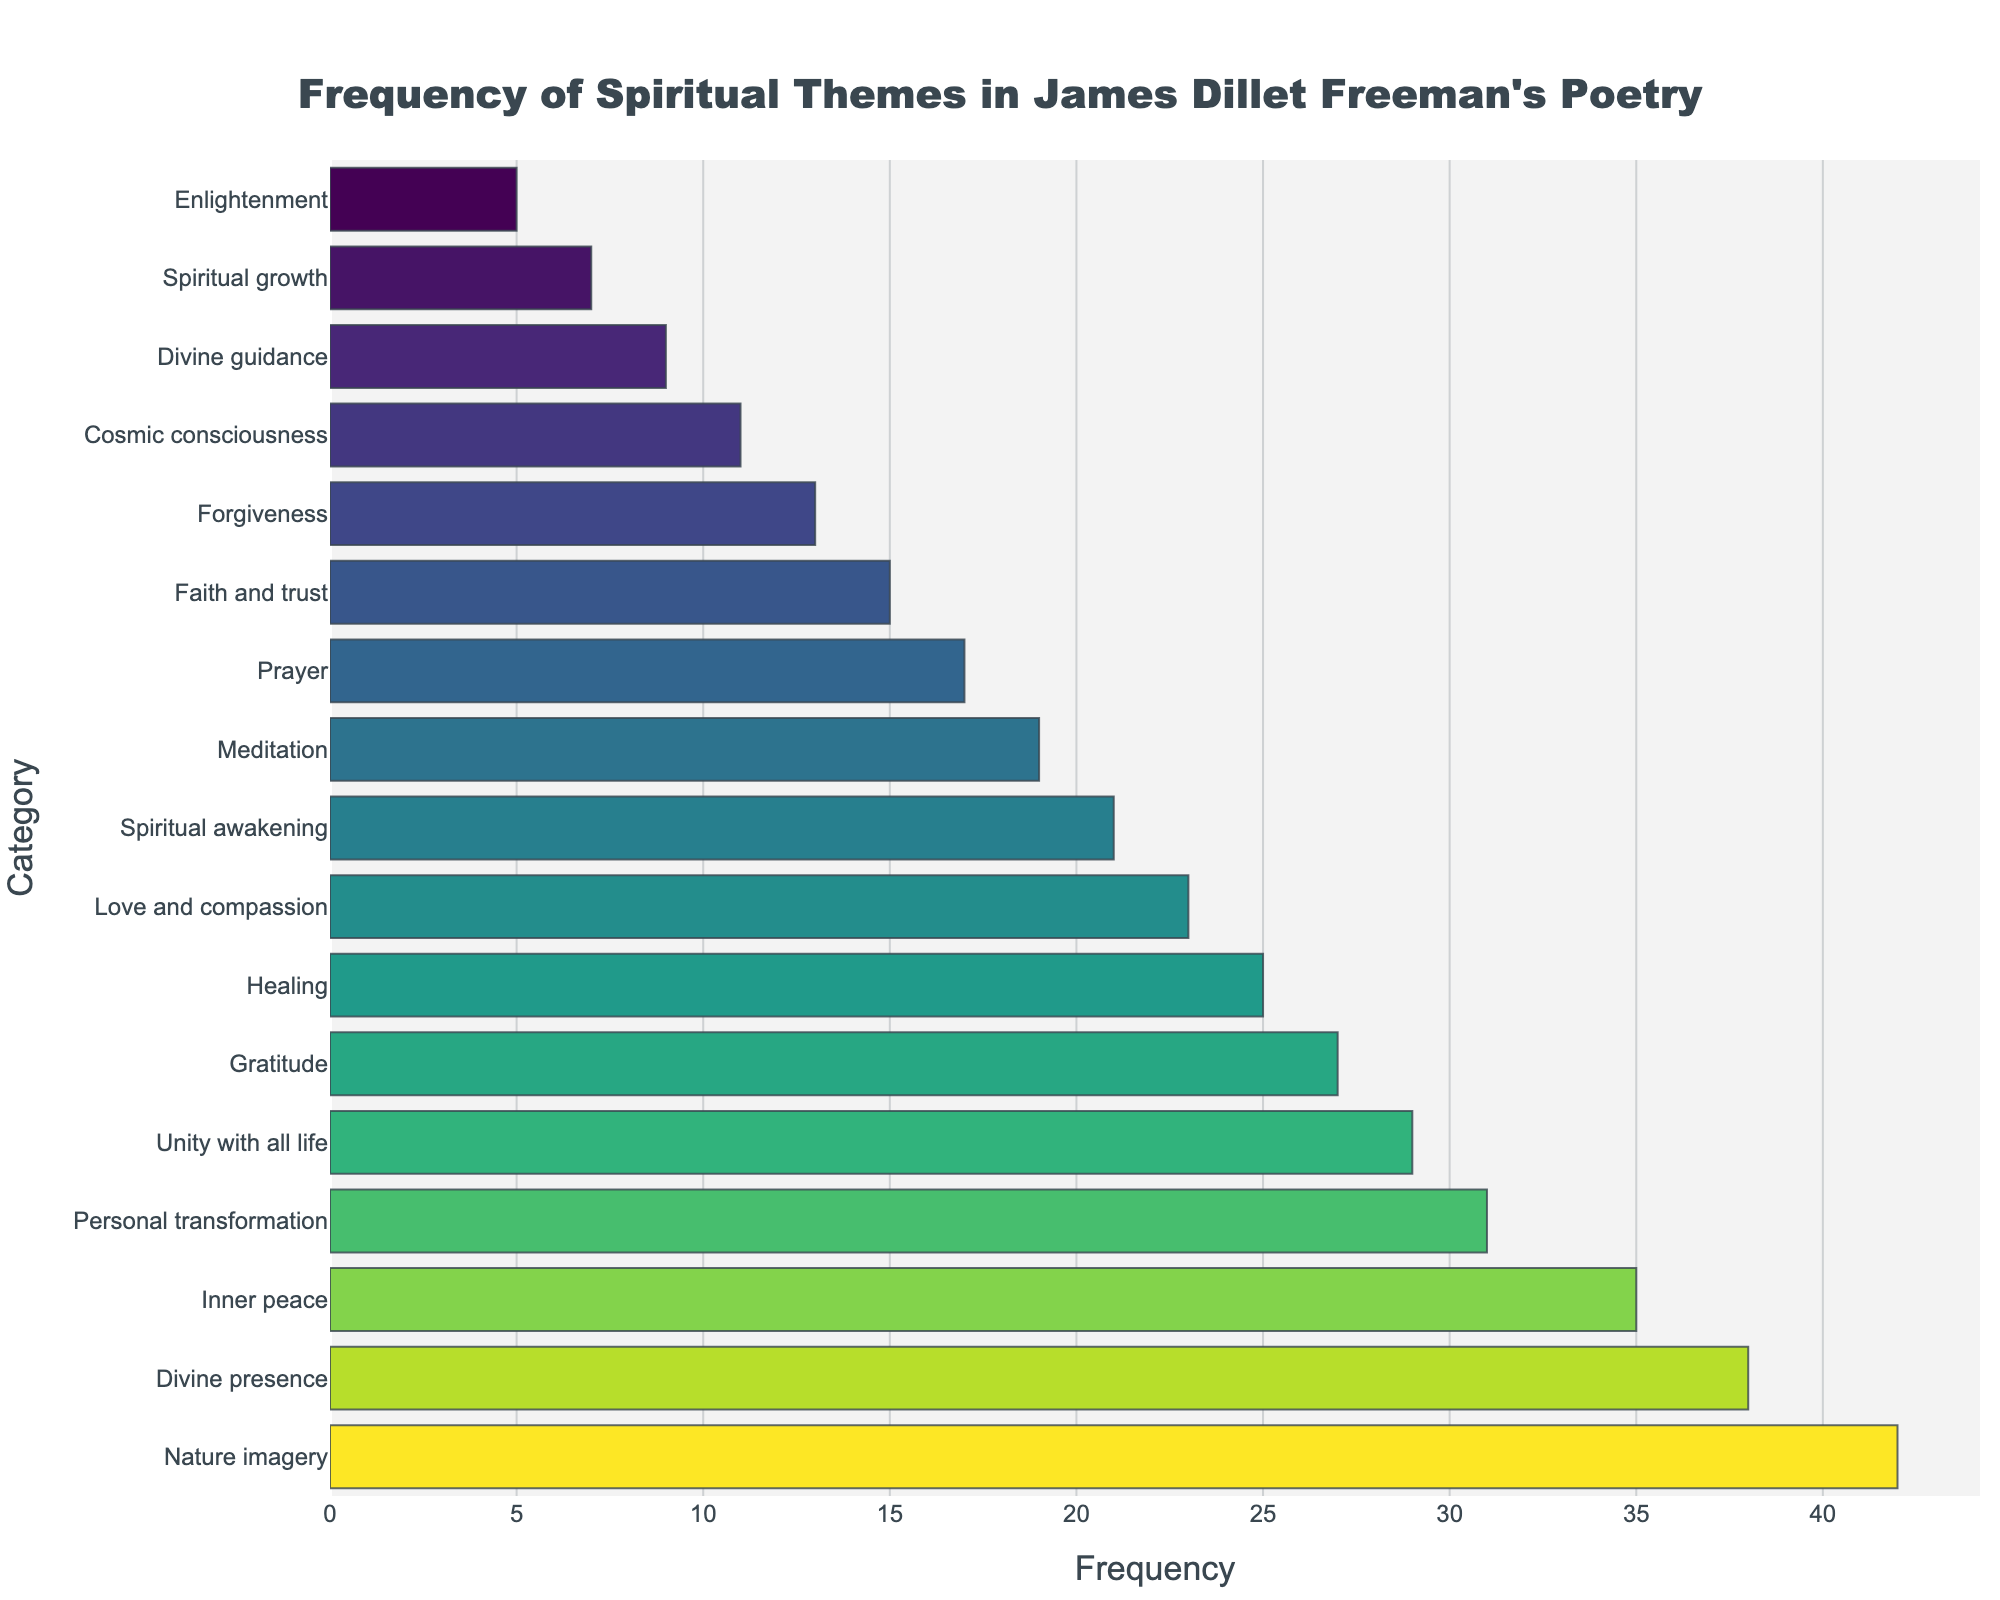What's the most frequently mentioned spiritual theme in James Dillet Freeman's poetry? The bar chart shows categories on the y-axis and their corresponding frequencies on the x-axis. The category with the longest bar is "Nature imagery", which sits at the top as the most frequent theme.
Answer: Nature imagery Which spiritual theme has a frequency closest to 20? Looking at the x-axis values for each bar, we find the nearest to 20 is "Spiritual awakening" with a frequency exactly matching 21.
Answer: Spiritual awakening Between "Divine presence" and "Inner peace," which theme is more frequently mentioned? Locate the lengths of the bars for "Divine presence" and "Inner peace". "Divine presence" has a frequency of 38, while "Inner peace" has a frequency of 35. "Divine presence" has the higher frequency.
Answer: Divine presence How many themes have a frequency of at least 30? Count all the bars that extend to at least the 30 mark on the x-axis. These include "Nature imagery", "Divine presence", "Inner peace", and "Personal transformation".
Answer: 4 What’s the difference in frequency between "Love and compassion" and "Healing"? "Healing" has a frequency of 25, while "Love and compassion" has a frequency of 23. Subtracting these gives 25 - 23 = 2.
Answer: 2 Which theme has the lowest frequency, and what is its value? Find the bar with the shortest length. It represents "Enlightenment" with a frequency of 5.
Answer: Enlightenment, 5 Are there more themes with frequencies above or below 20? Count the themes with frequencies above 20: "Nature imagery", "Divine presence", "Inner peace", "Personal transformation", "Unity with all life", and "Gratitude". This yields 6 themes. Count the themes with frequencies below 20: There are 12 themes.
Answer: Below Across all themes with frequencies under 10, what is the total frequency? Add frequencies of categories with values under 10: "Divine guidance" (9), "Spiritual growth" (7), and "Enlightenment" (5). Total is 9 + 7 + 5 = 21.
Answer: 21 